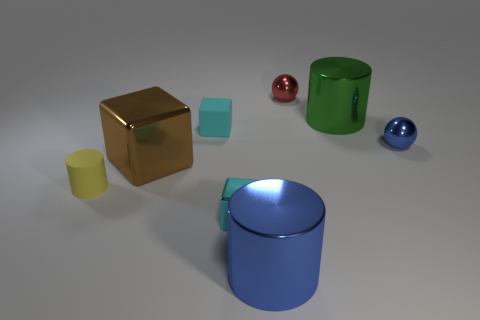What is the size of the cube that is left of the matte block?
Ensure brevity in your answer.  Large. Does the tiny metal block have the same color as the small block behind the cyan metallic cube?
Provide a succinct answer. Yes. Are there any small metallic blocks of the same color as the matte cube?
Ensure brevity in your answer.  Yes. Does the big brown block have the same material as the cylinder that is behind the brown cube?
Offer a terse response. Yes. How many tiny things are either red balls or cyan shiny things?
Provide a succinct answer. 2. There is another tiny block that is the same color as the tiny metallic block; what is its material?
Your response must be concise. Rubber. Are there fewer tiny red metal spheres than blue metallic objects?
Ensure brevity in your answer.  Yes. Is the size of the metal cylinder behind the big blue thing the same as the blue object that is to the right of the red shiny object?
Keep it short and to the point. No. How many yellow things are either small rubber blocks or big shiny cylinders?
Your answer should be compact. 0. Is the number of rubber things greater than the number of big green things?
Keep it short and to the point. Yes. 